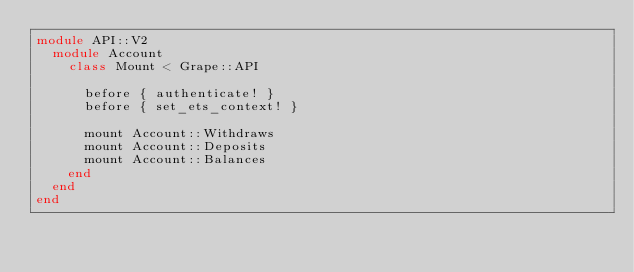<code> <loc_0><loc_0><loc_500><loc_500><_Ruby_>module API::V2
  module Account
    class Mount < Grape::API

      before { authenticate! }
      before { set_ets_context! }

      mount Account::Withdraws
      mount Account::Deposits
      mount Account::Balances
    end
  end
end
</code> 